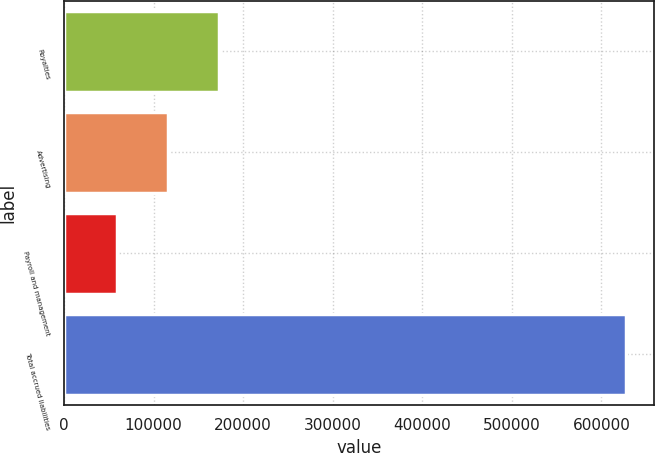<chart> <loc_0><loc_0><loc_500><loc_500><bar_chart><fcel>Royalties<fcel>Advertising<fcel>Payroll and management<fcel>Total accrued liabilities<nl><fcel>172666<fcel>115868<fcel>59070<fcel>627050<nl></chart> 